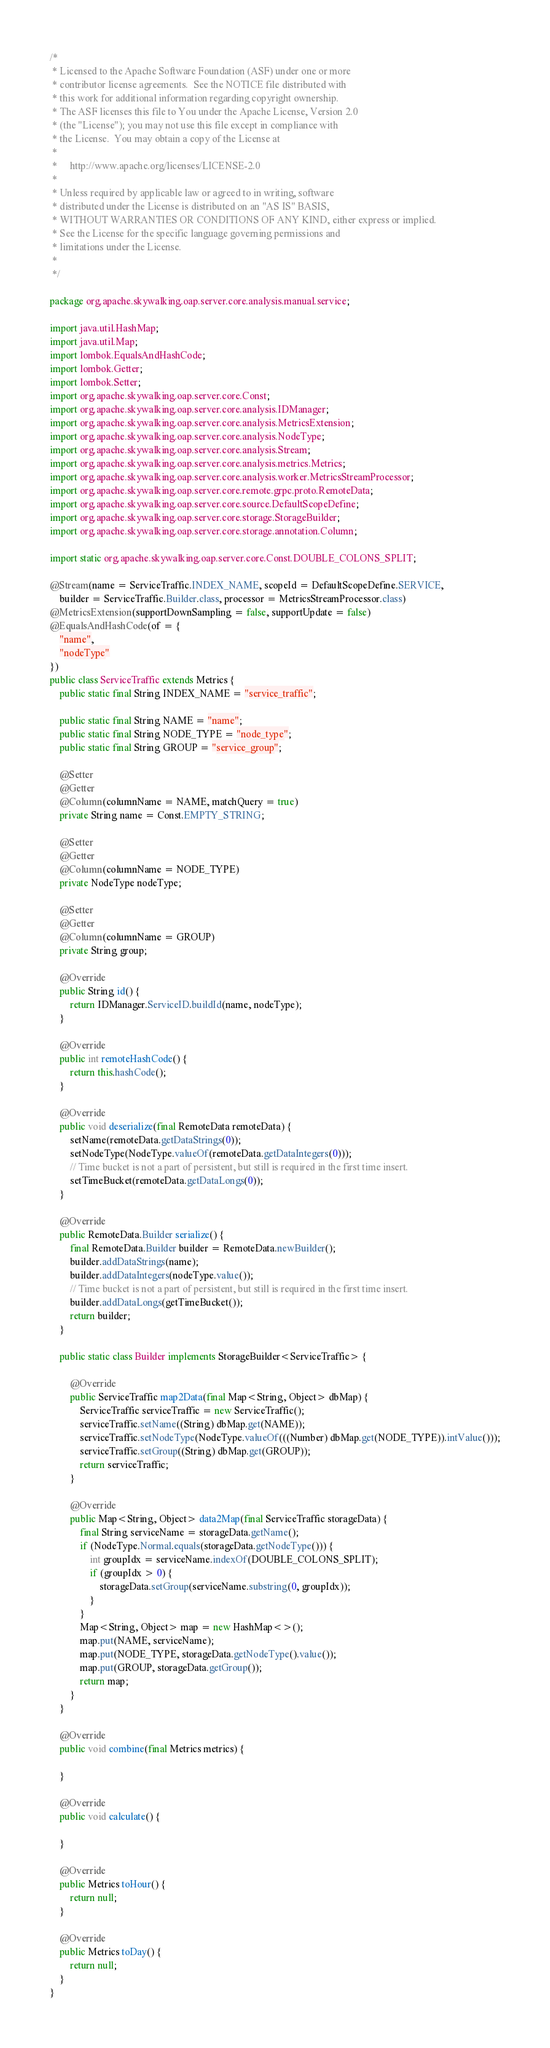Convert code to text. <code><loc_0><loc_0><loc_500><loc_500><_Java_>/*
 * Licensed to the Apache Software Foundation (ASF) under one or more
 * contributor license agreements.  See the NOTICE file distributed with
 * this work for additional information regarding copyright ownership.
 * The ASF licenses this file to You under the Apache License, Version 2.0
 * (the "License"); you may not use this file except in compliance with
 * the License.  You may obtain a copy of the License at
 *
 *     http://www.apache.org/licenses/LICENSE-2.0
 *
 * Unless required by applicable law or agreed to in writing, software
 * distributed under the License is distributed on an "AS IS" BASIS,
 * WITHOUT WARRANTIES OR CONDITIONS OF ANY KIND, either express or implied.
 * See the License for the specific language governing permissions and
 * limitations under the License.
 *
 */

package org.apache.skywalking.oap.server.core.analysis.manual.service;

import java.util.HashMap;
import java.util.Map;
import lombok.EqualsAndHashCode;
import lombok.Getter;
import lombok.Setter;
import org.apache.skywalking.oap.server.core.Const;
import org.apache.skywalking.oap.server.core.analysis.IDManager;
import org.apache.skywalking.oap.server.core.analysis.MetricsExtension;
import org.apache.skywalking.oap.server.core.analysis.NodeType;
import org.apache.skywalking.oap.server.core.analysis.Stream;
import org.apache.skywalking.oap.server.core.analysis.metrics.Metrics;
import org.apache.skywalking.oap.server.core.analysis.worker.MetricsStreamProcessor;
import org.apache.skywalking.oap.server.core.remote.grpc.proto.RemoteData;
import org.apache.skywalking.oap.server.core.source.DefaultScopeDefine;
import org.apache.skywalking.oap.server.core.storage.StorageBuilder;
import org.apache.skywalking.oap.server.core.storage.annotation.Column;

import static org.apache.skywalking.oap.server.core.Const.DOUBLE_COLONS_SPLIT;

@Stream(name = ServiceTraffic.INDEX_NAME, scopeId = DefaultScopeDefine.SERVICE,
    builder = ServiceTraffic.Builder.class, processor = MetricsStreamProcessor.class)
@MetricsExtension(supportDownSampling = false, supportUpdate = false)
@EqualsAndHashCode(of = {
    "name",
    "nodeType"
})
public class ServiceTraffic extends Metrics {
    public static final String INDEX_NAME = "service_traffic";

    public static final String NAME = "name";
    public static final String NODE_TYPE = "node_type";
    public static final String GROUP = "service_group";

    @Setter
    @Getter
    @Column(columnName = NAME, matchQuery = true)
    private String name = Const.EMPTY_STRING;

    @Setter
    @Getter
    @Column(columnName = NODE_TYPE)
    private NodeType nodeType;

    @Setter
    @Getter
    @Column(columnName = GROUP)
    private String group;

    @Override
    public String id() {
        return IDManager.ServiceID.buildId(name, nodeType);
    }

    @Override
    public int remoteHashCode() {
        return this.hashCode();
    }

    @Override
    public void deserialize(final RemoteData remoteData) {
        setName(remoteData.getDataStrings(0));
        setNodeType(NodeType.valueOf(remoteData.getDataIntegers(0)));
        // Time bucket is not a part of persistent, but still is required in the first time insert.
        setTimeBucket(remoteData.getDataLongs(0));
    }

    @Override
    public RemoteData.Builder serialize() {
        final RemoteData.Builder builder = RemoteData.newBuilder();
        builder.addDataStrings(name);
        builder.addDataIntegers(nodeType.value());
        // Time bucket is not a part of persistent, but still is required in the first time insert.
        builder.addDataLongs(getTimeBucket());
        return builder;
    }

    public static class Builder implements StorageBuilder<ServiceTraffic> {

        @Override
        public ServiceTraffic map2Data(final Map<String, Object> dbMap) {
            ServiceTraffic serviceTraffic = new ServiceTraffic();
            serviceTraffic.setName((String) dbMap.get(NAME));
            serviceTraffic.setNodeType(NodeType.valueOf(((Number) dbMap.get(NODE_TYPE)).intValue()));
            serviceTraffic.setGroup((String) dbMap.get(GROUP));
            return serviceTraffic;
        }

        @Override
        public Map<String, Object> data2Map(final ServiceTraffic storageData) {
            final String serviceName = storageData.getName();
            if (NodeType.Normal.equals(storageData.getNodeType())) {
                int groupIdx = serviceName.indexOf(DOUBLE_COLONS_SPLIT);
                if (groupIdx > 0) {
                    storageData.setGroup(serviceName.substring(0, groupIdx));
                }
            }
            Map<String, Object> map = new HashMap<>();
            map.put(NAME, serviceName);
            map.put(NODE_TYPE, storageData.getNodeType().value());
            map.put(GROUP, storageData.getGroup());
            return map;
        }
    }

    @Override
    public void combine(final Metrics metrics) {

    }

    @Override
    public void calculate() {

    }

    @Override
    public Metrics toHour() {
        return null;
    }

    @Override
    public Metrics toDay() {
        return null;
    }
}

</code> 